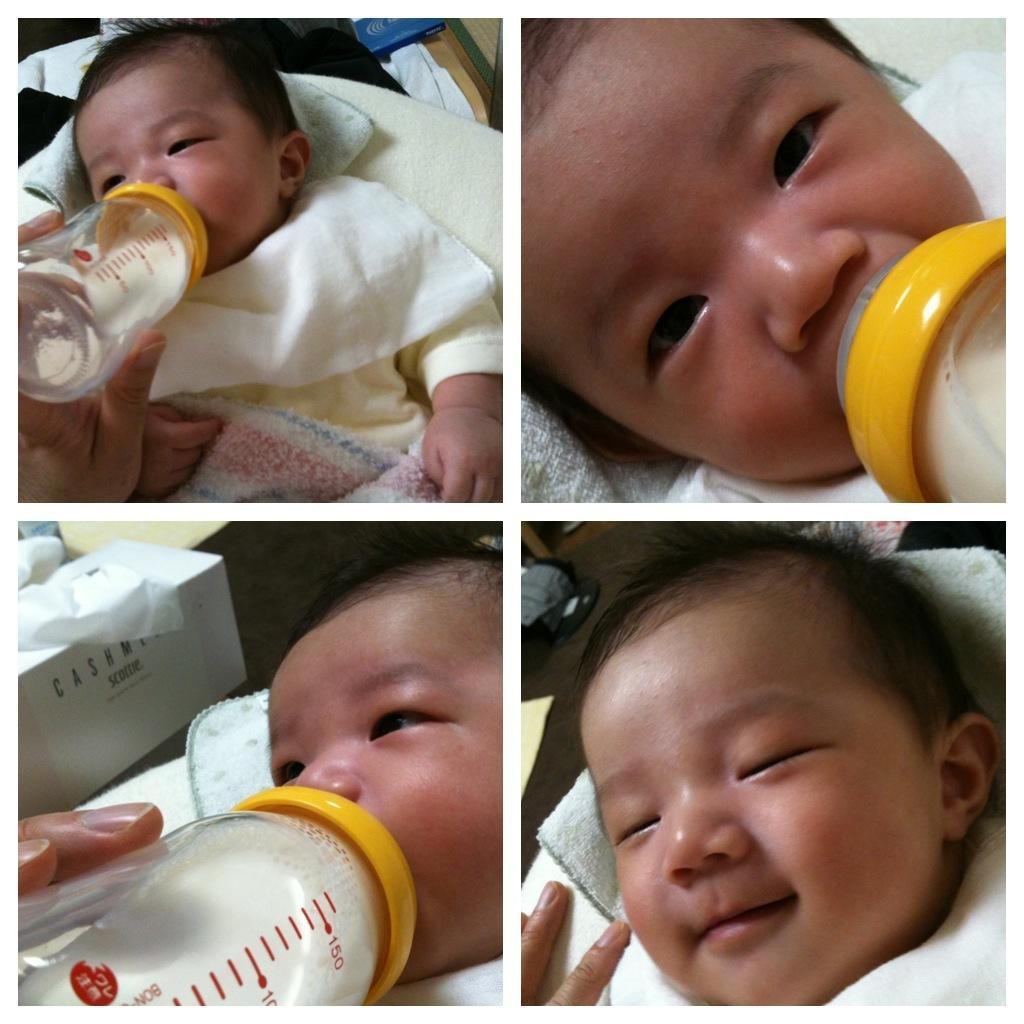Could you give a brief overview of what you see in this image? This picture shows a baby and we have similar pictures as a collage. baby drinking milk in the bottle 